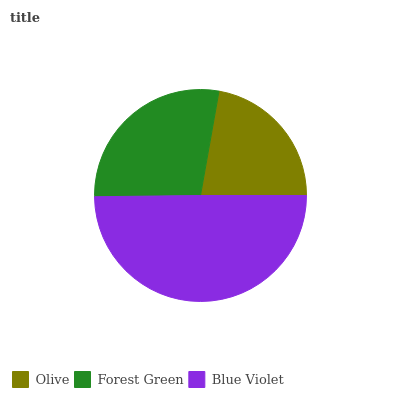Is Olive the minimum?
Answer yes or no. Yes. Is Blue Violet the maximum?
Answer yes or no. Yes. Is Forest Green the minimum?
Answer yes or no. No. Is Forest Green the maximum?
Answer yes or no. No. Is Forest Green greater than Olive?
Answer yes or no. Yes. Is Olive less than Forest Green?
Answer yes or no. Yes. Is Olive greater than Forest Green?
Answer yes or no. No. Is Forest Green less than Olive?
Answer yes or no. No. Is Forest Green the high median?
Answer yes or no. Yes. Is Forest Green the low median?
Answer yes or no. Yes. Is Olive the high median?
Answer yes or no. No. Is Blue Violet the low median?
Answer yes or no. No. 